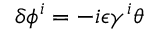Convert formula to latex. <formula><loc_0><loc_0><loc_500><loc_500>\delta \phi ^ { i } = - i \epsilon \gamma ^ { i } \theta</formula> 